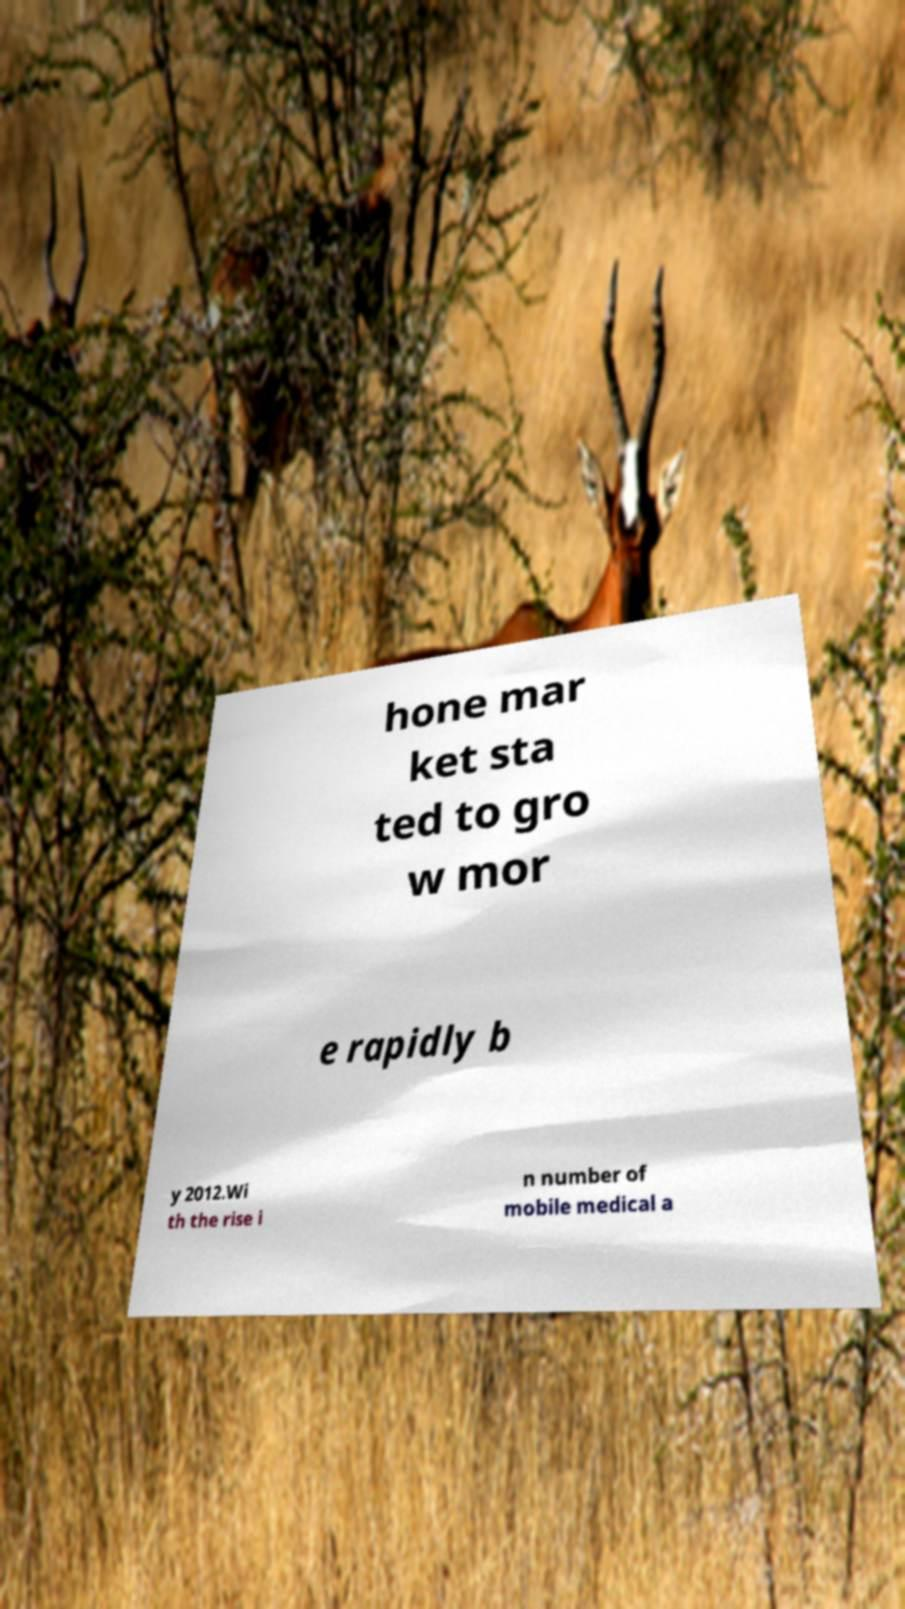Please read and relay the text visible in this image. What does it say? hone mar ket sta ted to gro w mor e rapidly b y 2012.Wi th the rise i n number of mobile medical a 